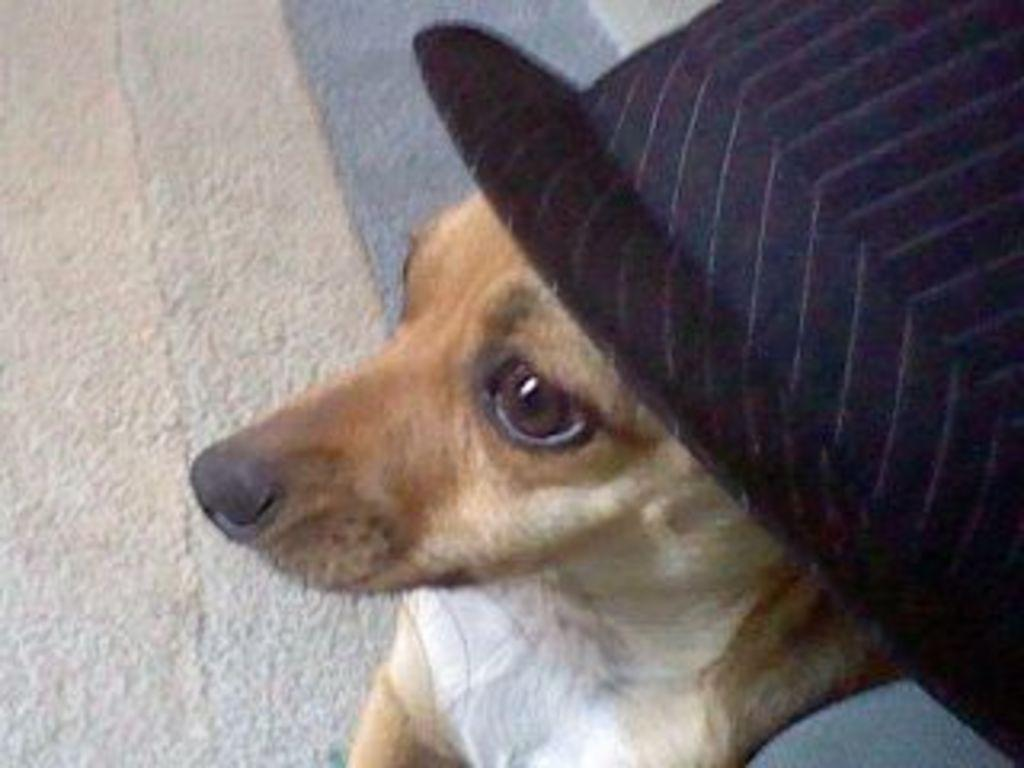What type of animal is present in the image? There is a dog in the image. What is the color of the dog in the image? The dog is brown in color. What type of accessory is visible in the image? There is a black color hat in the image. What type of spring is visible in the image? There is no spring present in the image. Is the dog playing volleyball in the image? There is no volleyball or indication of motion in the image; the dog is simply present. 